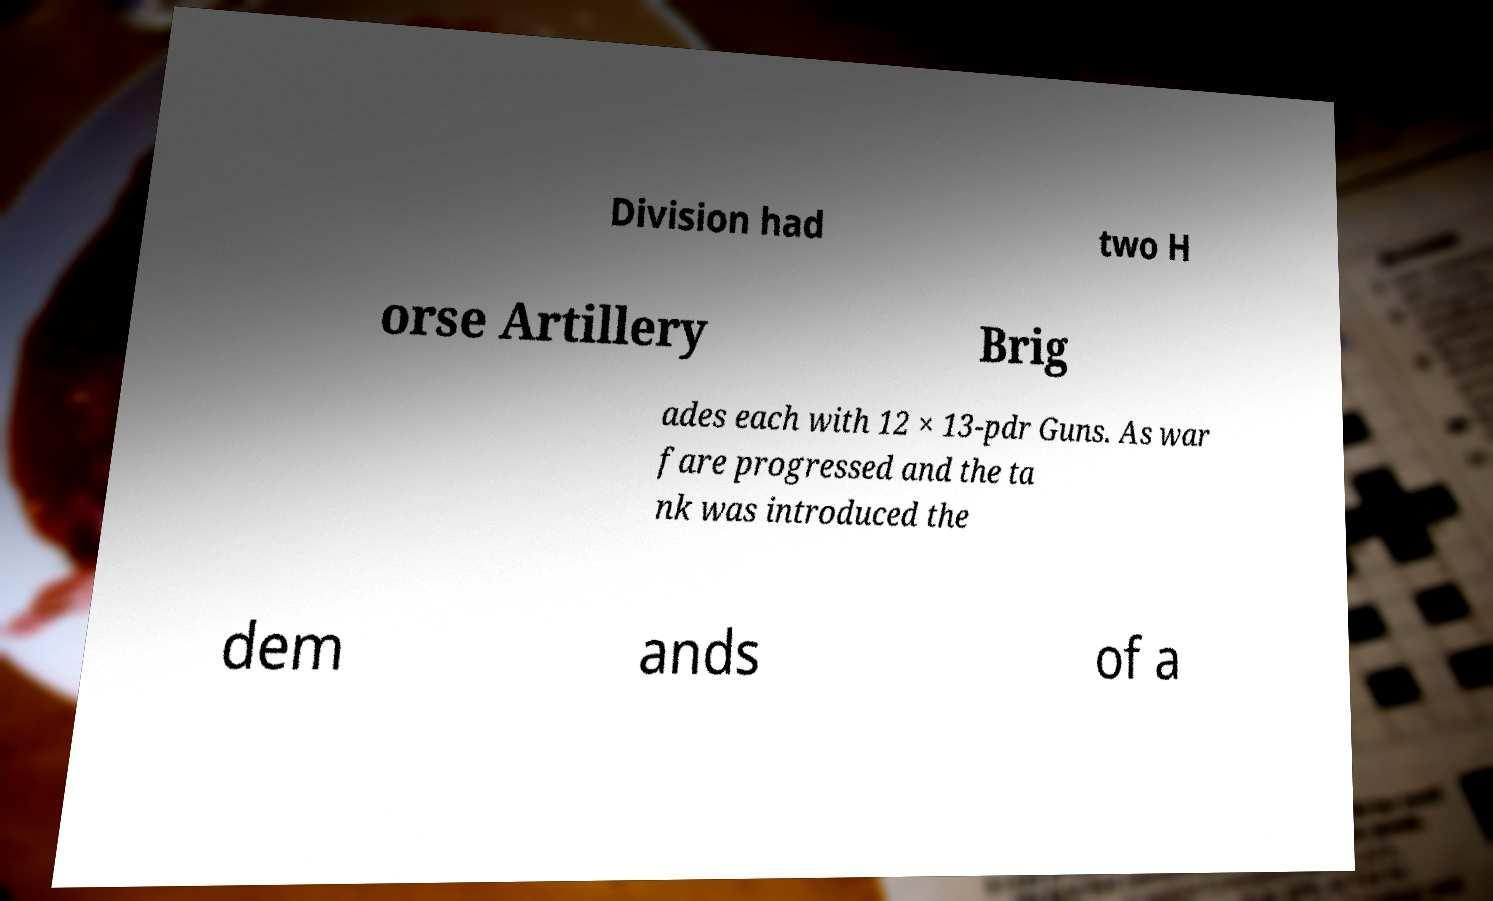Please read and relay the text visible in this image. What does it say? Division had two H orse Artillery Brig ades each with 12 × 13-pdr Guns. As war fare progressed and the ta nk was introduced the dem ands of a 